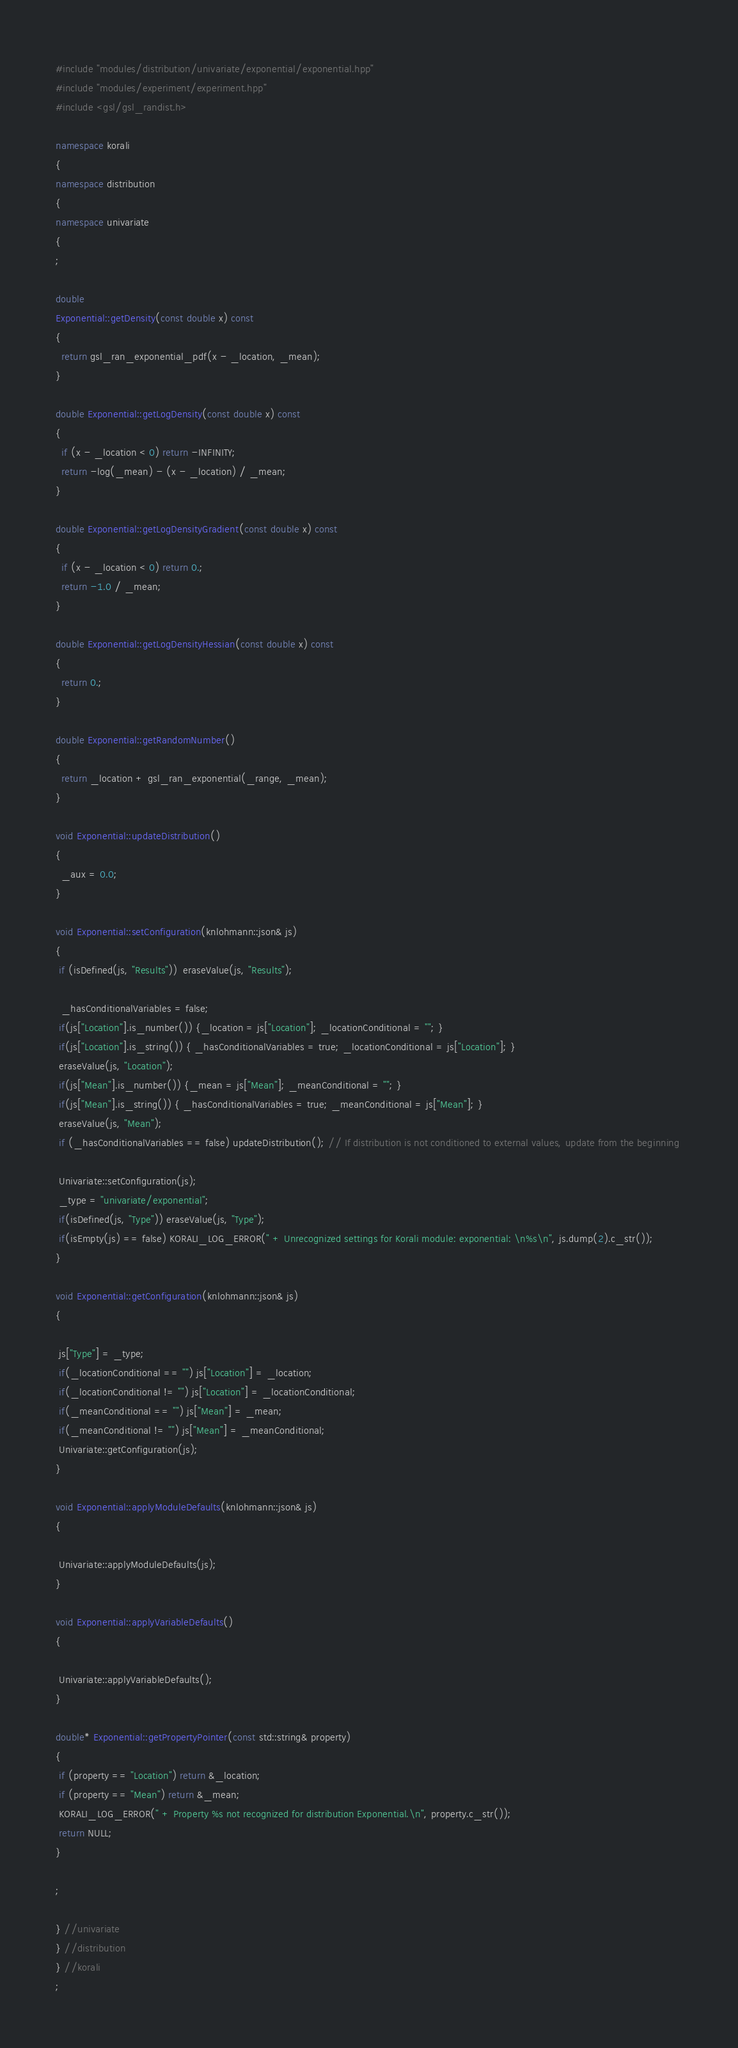<code> <loc_0><loc_0><loc_500><loc_500><_C++_>#include "modules/distribution/univariate/exponential/exponential.hpp"
#include "modules/experiment/experiment.hpp"
#include <gsl/gsl_randist.h>

namespace korali
{
namespace distribution
{
namespace univariate
{
;

double
Exponential::getDensity(const double x) const
{
  return gsl_ran_exponential_pdf(x - _location, _mean);
}

double Exponential::getLogDensity(const double x) const
{
  if (x - _location < 0) return -INFINITY;
  return -log(_mean) - (x - _location) / _mean;
}

double Exponential::getLogDensityGradient(const double x) const
{
  if (x - _location < 0) return 0.;
  return -1.0 / _mean;
}

double Exponential::getLogDensityHessian(const double x) const
{
  return 0.;
}

double Exponential::getRandomNumber()
{
  return _location + gsl_ran_exponential(_range, _mean);
}

void Exponential::updateDistribution()
{
  _aux = 0.0;
}

void Exponential::setConfiguration(knlohmann::json& js) 
{
 if (isDefined(js, "Results"))  eraseValue(js, "Results");

  _hasConditionalVariables = false; 
 if(js["Location"].is_number()) {_location = js["Location"]; _locationConditional = ""; } 
 if(js["Location"].is_string()) { _hasConditionalVariables = true; _locationConditional = js["Location"]; } 
 eraseValue(js, "Location");
 if(js["Mean"].is_number()) {_mean = js["Mean"]; _meanConditional = ""; } 
 if(js["Mean"].is_string()) { _hasConditionalVariables = true; _meanConditional = js["Mean"]; } 
 eraseValue(js, "Mean");
 if (_hasConditionalVariables == false) updateDistribution(); // If distribution is not conditioned to external values, update from the beginning 

 Univariate::setConfiguration(js);
 _type = "univariate/exponential";
 if(isDefined(js, "Type")) eraseValue(js, "Type");
 if(isEmpty(js) == false) KORALI_LOG_ERROR(" + Unrecognized settings for Korali module: exponential: \n%s\n", js.dump(2).c_str());
} 

void Exponential::getConfiguration(knlohmann::json& js) 
{

 js["Type"] = _type;
 if(_locationConditional == "") js["Location"] = _location;
 if(_locationConditional != "") js["Location"] = _locationConditional; 
 if(_meanConditional == "") js["Mean"] = _mean;
 if(_meanConditional != "") js["Mean"] = _meanConditional; 
 Univariate::getConfiguration(js);
} 

void Exponential::applyModuleDefaults(knlohmann::json& js) 
{

 Univariate::applyModuleDefaults(js);
} 

void Exponential::applyVariableDefaults() 
{

 Univariate::applyVariableDefaults();
} 

double* Exponential::getPropertyPointer(const std::string& property)
{
 if (property == "Location") return &_location;
 if (property == "Mean") return &_mean;
 KORALI_LOG_ERROR(" + Property %s not recognized for distribution Exponential.\n", property.c_str());
 return NULL;
}

;

} //univariate
} //distribution
} //korali
;
</code> 